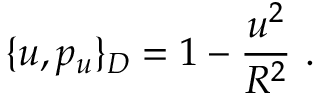Convert formula to latex. <formula><loc_0><loc_0><loc_500><loc_500>\{ u , p _ { u } \} _ { D } = 1 - \frac { u ^ { 2 } } { R ^ { 2 } } \ .</formula> 